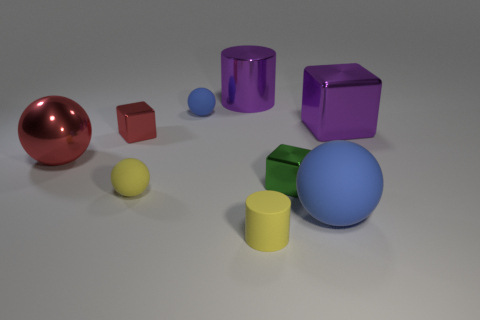There is a small red object; what shape is it?
Keep it short and to the point. Cube. Does the blue matte ball in front of the large purple block have the same size as the cube that is in front of the large red metal ball?
Your answer should be compact. No. There is a blue ball that is in front of the small metal cube that is on the left side of the shiny thing that is in front of the large red object; how big is it?
Give a very brief answer. Large. There is a object left of the tiny metal object behind the shiny ball behind the rubber cylinder; what is its shape?
Ensure brevity in your answer.  Sphere. There is a purple shiny object to the left of the green thing; what shape is it?
Make the answer very short. Cylinder. Are the large cylinder and the blue thing left of the purple metal cylinder made of the same material?
Make the answer very short. No. How many other things are there of the same shape as the tiny green thing?
Provide a short and direct response. 2. There is a large rubber object; is its color the same as the tiny object to the right of the yellow cylinder?
Your answer should be very brief. No. There is a tiny rubber thing in front of the blue rubber object in front of the tiny blue rubber ball; what is its shape?
Give a very brief answer. Cylinder. The metal cylinder that is the same color as the large block is what size?
Keep it short and to the point. Large. 